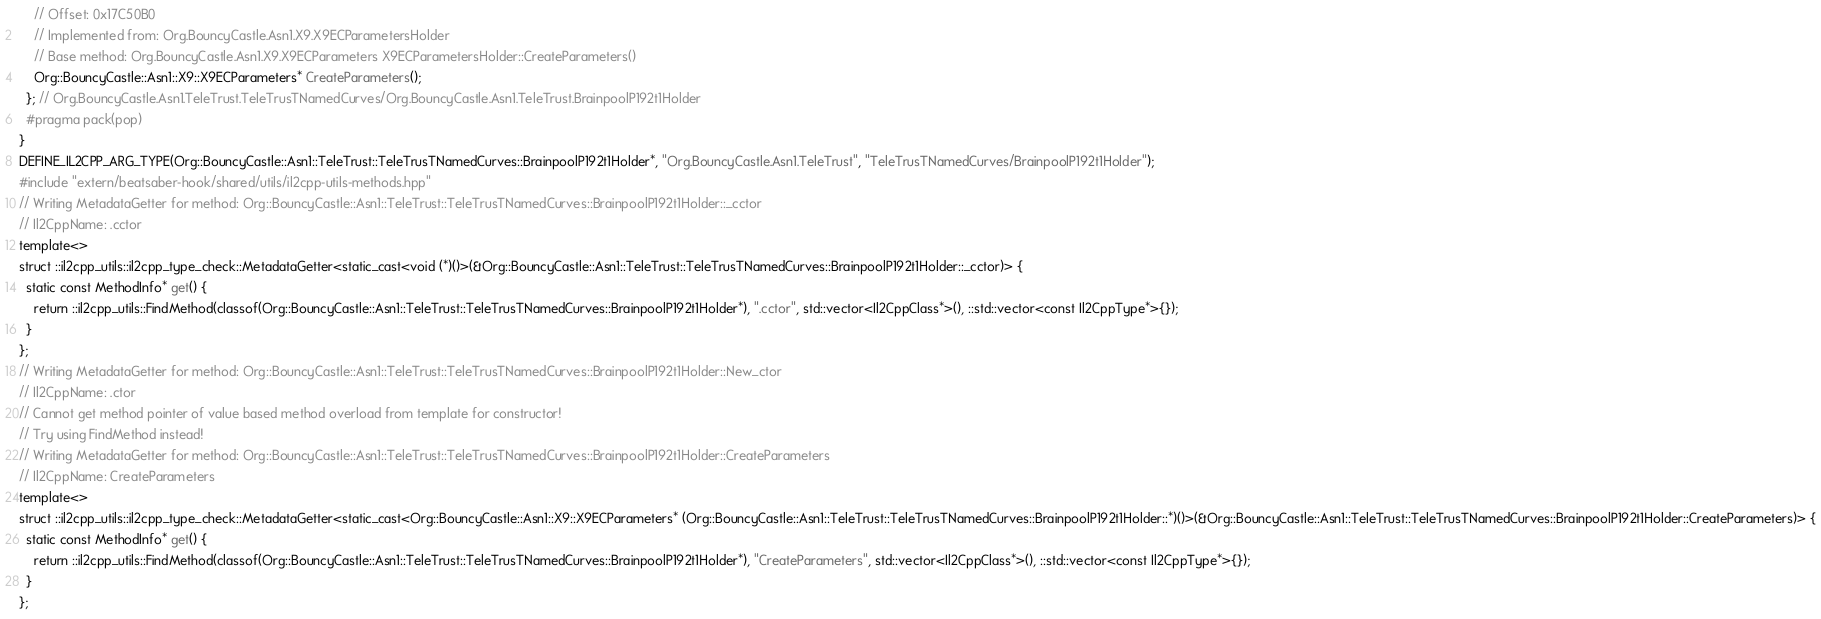Convert code to text. <code><loc_0><loc_0><loc_500><loc_500><_C++_>    // Offset: 0x17C50B0
    // Implemented from: Org.BouncyCastle.Asn1.X9.X9ECParametersHolder
    // Base method: Org.BouncyCastle.Asn1.X9.X9ECParameters X9ECParametersHolder::CreateParameters()
    Org::BouncyCastle::Asn1::X9::X9ECParameters* CreateParameters();
  }; // Org.BouncyCastle.Asn1.TeleTrust.TeleTrusTNamedCurves/Org.BouncyCastle.Asn1.TeleTrust.BrainpoolP192t1Holder
  #pragma pack(pop)
}
DEFINE_IL2CPP_ARG_TYPE(Org::BouncyCastle::Asn1::TeleTrust::TeleTrusTNamedCurves::BrainpoolP192t1Holder*, "Org.BouncyCastle.Asn1.TeleTrust", "TeleTrusTNamedCurves/BrainpoolP192t1Holder");
#include "extern/beatsaber-hook/shared/utils/il2cpp-utils-methods.hpp"
// Writing MetadataGetter for method: Org::BouncyCastle::Asn1::TeleTrust::TeleTrusTNamedCurves::BrainpoolP192t1Holder::_cctor
// Il2CppName: .cctor
template<>
struct ::il2cpp_utils::il2cpp_type_check::MetadataGetter<static_cast<void (*)()>(&Org::BouncyCastle::Asn1::TeleTrust::TeleTrusTNamedCurves::BrainpoolP192t1Holder::_cctor)> {
  static const MethodInfo* get() {
    return ::il2cpp_utils::FindMethod(classof(Org::BouncyCastle::Asn1::TeleTrust::TeleTrusTNamedCurves::BrainpoolP192t1Holder*), ".cctor", std::vector<Il2CppClass*>(), ::std::vector<const Il2CppType*>{});
  }
};
// Writing MetadataGetter for method: Org::BouncyCastle::Asn1::TeleTrust::TeleTrusTNamedCurves::BrainpoolP192t1Holder::New_ctor
// Il2CppName: .ctor
// Cannot get method pointer of value based method overload from template for constructor!
// Try using FindMethod instead!
// Writing MetadataGetter for method: Org::BouncyCastle::Asn1::TeleTrust::TeleTrusTNamedCurves::BrainpoolP192t1Holder::CreateParameters
// Il2CppName: CreateParameters
template<>
struct ::il2cpp_utils::il2cpp_type_check::MetadataGetter<static_cast<Org::BouncyCastle::Asn1::X9::X9ECParameters* (Org::BouncyCastle::Asn1::TeleTrust::TeleTrusTNamedCurves::BrainpoolP192t1Holder::*)()>(&Org::BouncyCastle::Asn1::TeleTrust::TeleTrusTNamedCurves::BrainpoolP192t1Holder::CreateParameters)> {
  static const MethodInfo* get() {
    return ::il2cpp_utils::FindMethod(classof(Org::BouncyCastle::Asn1::TeleTrust::TeleTrusTNamedCurves::BrainpoolP192t1Holder*), "CreateParameters", std::vector<Il2CppClass*>(), ::std::vector<const Il2CppType*>{});
  }
};
</code> 